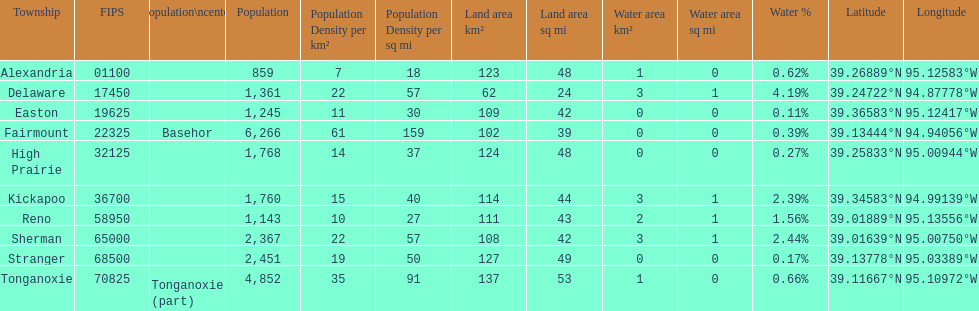What is the number of townships with a population larger than 2,000? 4. 